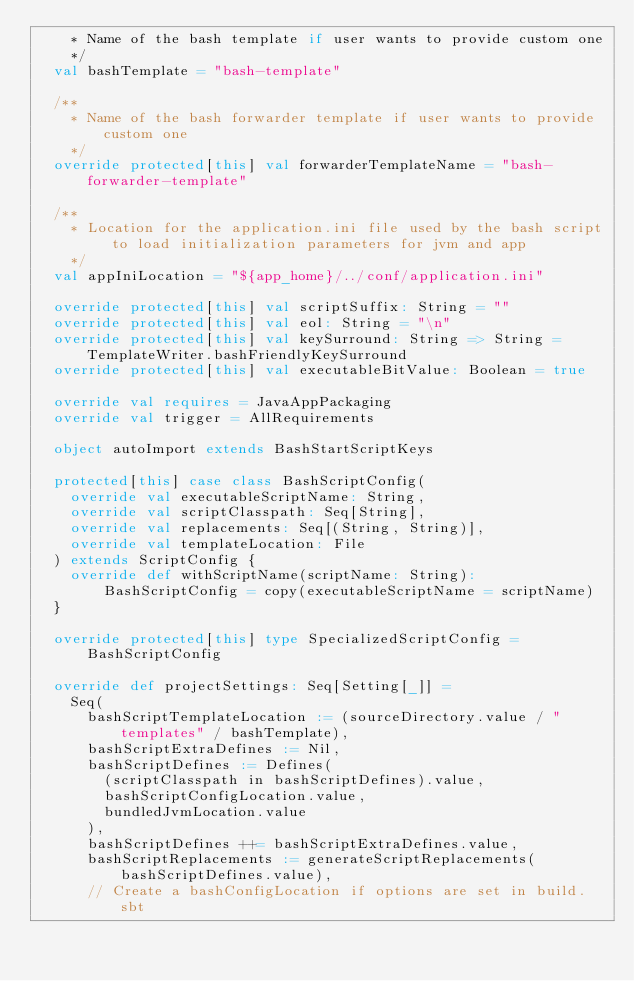Convert code to text. <code><loc_0><loc_0><loc_500><loc_500><_Scala_>    * Name of the bash template if user wants to provide custom one
    */
  val bashTemplate = "bash-template"

  /**
    * Name of the bash forwarder template if user wants to provide custom one
    */
  override protected[this] val forwarderTemplateName = "bash-forwarder-template"

  /**
    * Location for the application.ini file used by the bash script to load initialization parameters for jvm and app
    */
  val appIniLocation = "${app_home}/../conf/application.ini"

  override protected[this] val scriptSuffix: String = ""
  override protected[this] val eol: String = "\n"
  override protected[this] val keySurround: String => String = TemplateWriter.bashFriendlyKeySurround
  override protected[this] val executableBitValue: Boolean = true

  override val requires = JavaAppPackaging
  override val trigger = AllRequirements

  object autoImport extends BashStartScriptKeys

  protected[this] case class BashScriptConfig(
    override val executableScriptName: String,
    override val scriptClasspath: Seq[String],
    override val replacements: Seq[(String, String)],
    override val templateLocation: File
  ) extends ScriptConfig {
    override def withScriptName(scriptName: String): BashScriptConfig = copy(executableScriptName = scriptName)
  }

  override protected[this] type SpecializedScriptConfig = BashScriptConfig

  override def projectSettings: Seq[Setting[_]] =
    Seq(
      bashScriptTemplateLocation := (sourceDirectory.value / "templates" / bashTemplate),
      bashScriptExtraDefines := Nil,
      bashScriptDefines := Defines(
        (scriptClasspath in bashScriptDefines).value,
        bashScriptConfigLocation.value,
        bundledJvmLocation.value
      ),
      bashScriptDefines ++= bashScriptExtraDefines.value,
      bashScriptReplacements := generateScriptReplacements(bashScriptDefines.value),
      // Create a bashConfigLocation if options are set in build.sbt</code> 